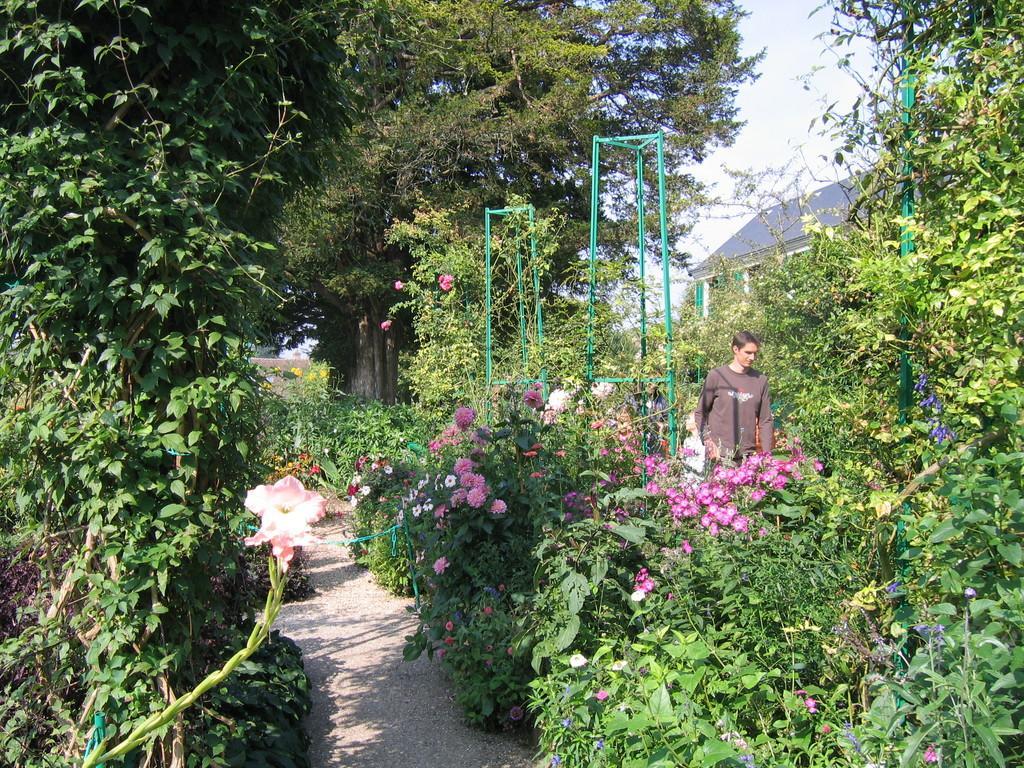Please provide a concise description of this image. The image is taken in the garden. In the center of the image we can see plants and flowers. At the bottom there is a walkway. On the right we can see a man walking. In the background there is a shed and sky. 